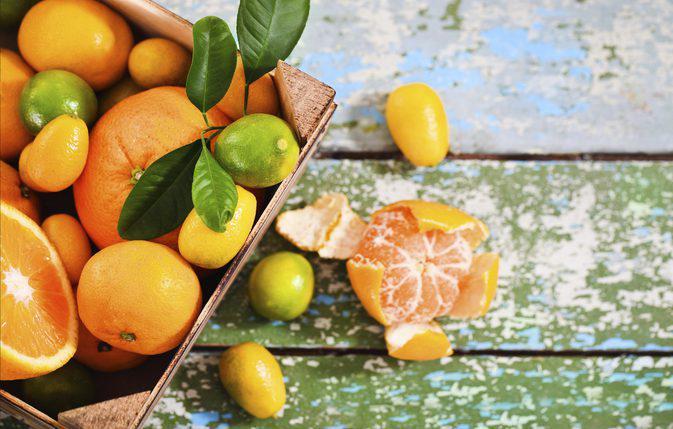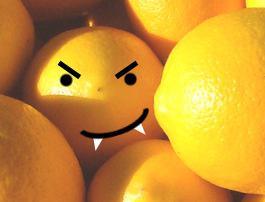The first image is the image on the left, the second image is the image on the right. For the images shown, is this caption "In at least one image there is a single lemon next to two green leaves." true? Answer yes or no. No. The first image is the image on the left, the second image is the image on the right. Analyze the images presented: Is the assertion "The left image includes a variety of whole citrus fruits, along with at least one cut fruit and green leaves." valid? Answer yes or no. Yes. 